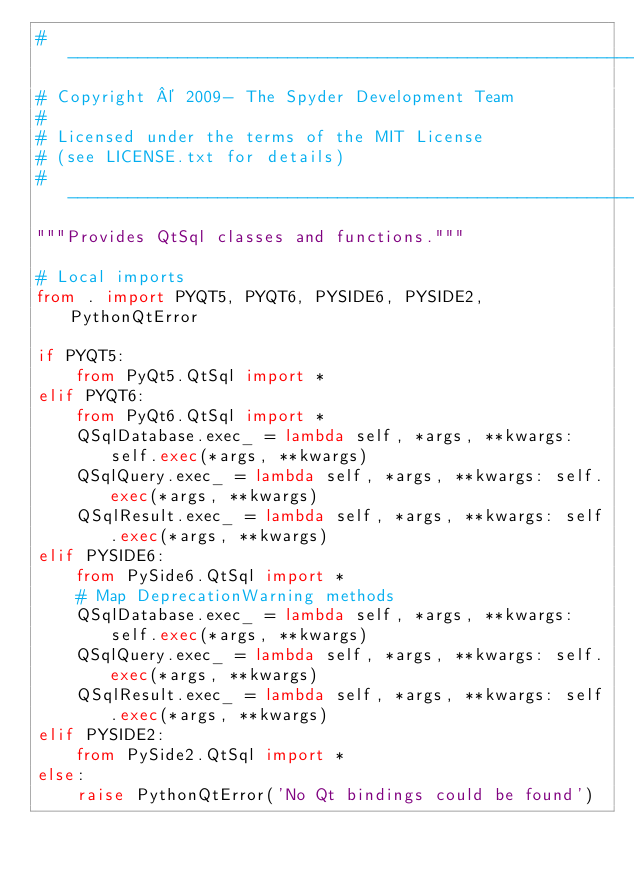Convert code to text. <code><loc_0><loc_0><loc_500><loc_500><_Python_># -----------------------------------------------------------------------------
# Copyright © 2009- The Spyder Development Team
#
# Licensed under the terms of the MIT License
# (see LICENSE.txt for details)
# -----------------------------------------------------------------------------
"""Provides QtSql classes and functions."""

# Local imports
from . import PYQT5, PYQT6, PYSIDE6, PYSIDE2, PythonQtError

if PYQT5:
    from PyQt5.QtSql import *
elif PYQT6:
    from PyQt6.QtSql import *
    QSqlDatabase.exec_ = lambda self, *args, **kwargs: self.exec(*args, **kwargs)
    QSqlQuery.exec_ = lambda self, *args, **kwargs: self.exec(*args, **kwargs)
    QSqlResult.exec_ = lambda self, *args, **kwargs: self.exec(*args, **kwargs)
elif PYSIDE6:
    from PySide6.QtSql import *
    # Map DeprecationWarning methods
    QSqlDatabase.exec_ = lambda self, *args, **kwargs: self.exec(*args, **kwargs)
    QSqlQuery.exec_ = lambda self, *args, **kwargs: self.exec(*args, **kwargs)
    QSqlResult.exec_ = lambda self, *args, **kwargs: self.exec(*args, **kwargs)
elif PYSIDE2:
    from PySide2.QtSql import *
else:
    raise PythonQtError('No Qt bindings could be found')

</code> 